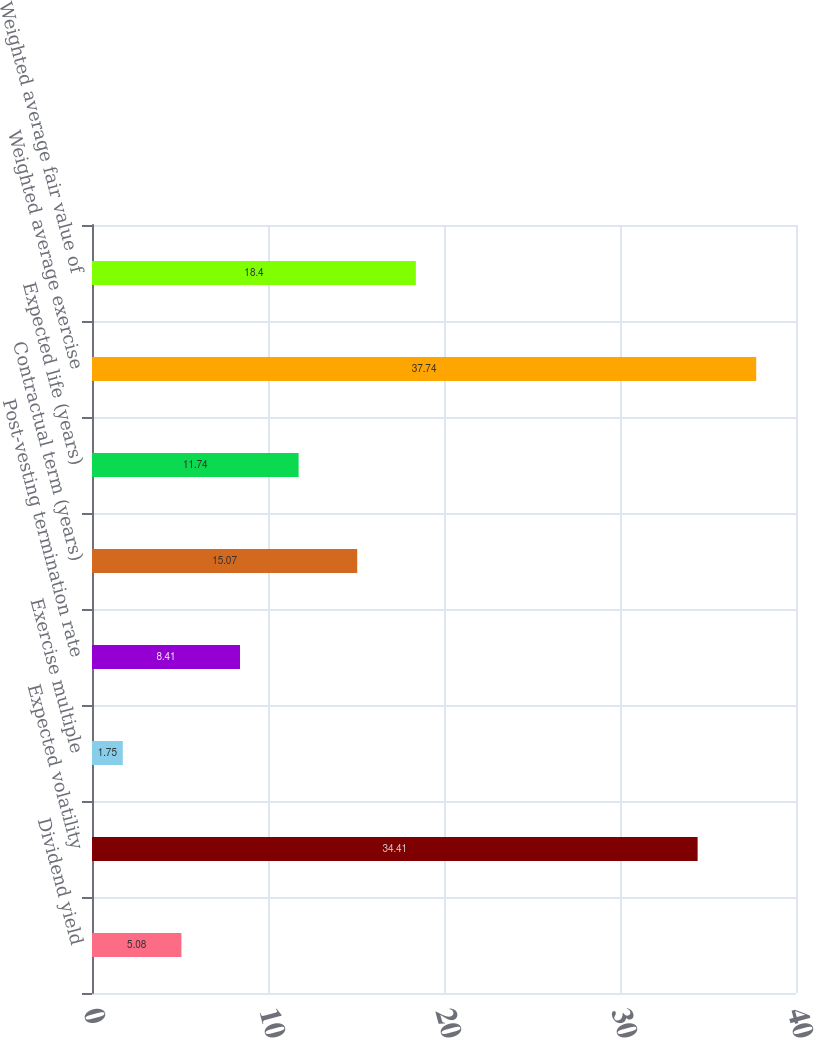Convert chart. <chart><loc_0><loc_0><loc_500><loc_500><bar_chart><fcel>Dividend yield<fcel>Expected volatility<fcel>Exercise multiple<fcel>Post-vesting termination rate<fcel>Contractual term (years)<fcel>Expected life (years)<fcel>Weighted average exercise<fcel>Weighted average fair value of<nl><fcel>5.08<fcel>34.41<fcel>1.75<fcel>8.41<fcel>15.07<fcel>11.74<fcel>37.74<fcel>18.4<nl></chart> 